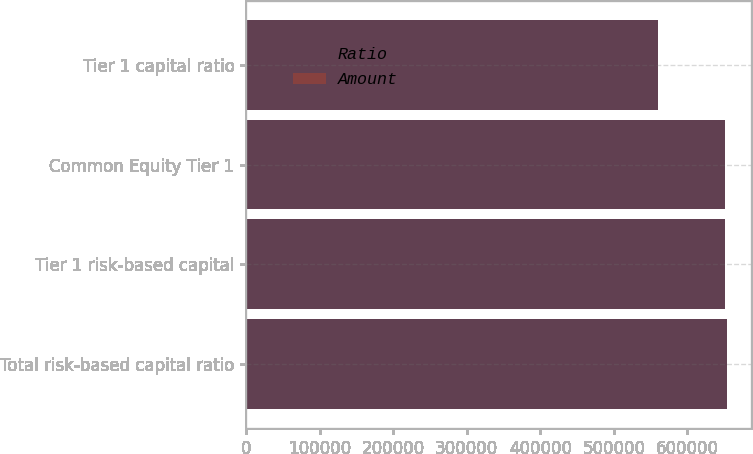Convert chart to OTSL. <chart><loc_0><loc_0><loc_500><loc_500><stacked_bar_chart><ecel><fcel>Total risk-based capital ratio<fcel>Tier 1 risk-based capital<fcel>Common Equity Tier 1<fcel>Tier 1 capital ratio<nl><fcel>Ratio<fcel>654053<fcel>650487<fcel>650487<fcel>559572<nl><fcel>Amount<fcel>236<fcel>234.7<fcel>234.7<fcel>32.1<nl></chart> 